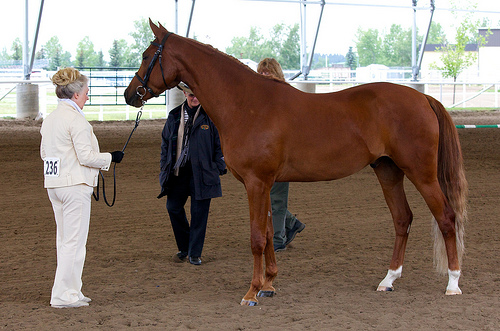<image>
Is the horse to the left of the women? No. The horse is not to the left of the women. From this viewpoint, they have a different horizontal relationship. Is the person in front of the horse? No. The person is not in front of the horse. The spatial positioning shows a different relationship between these objects. 